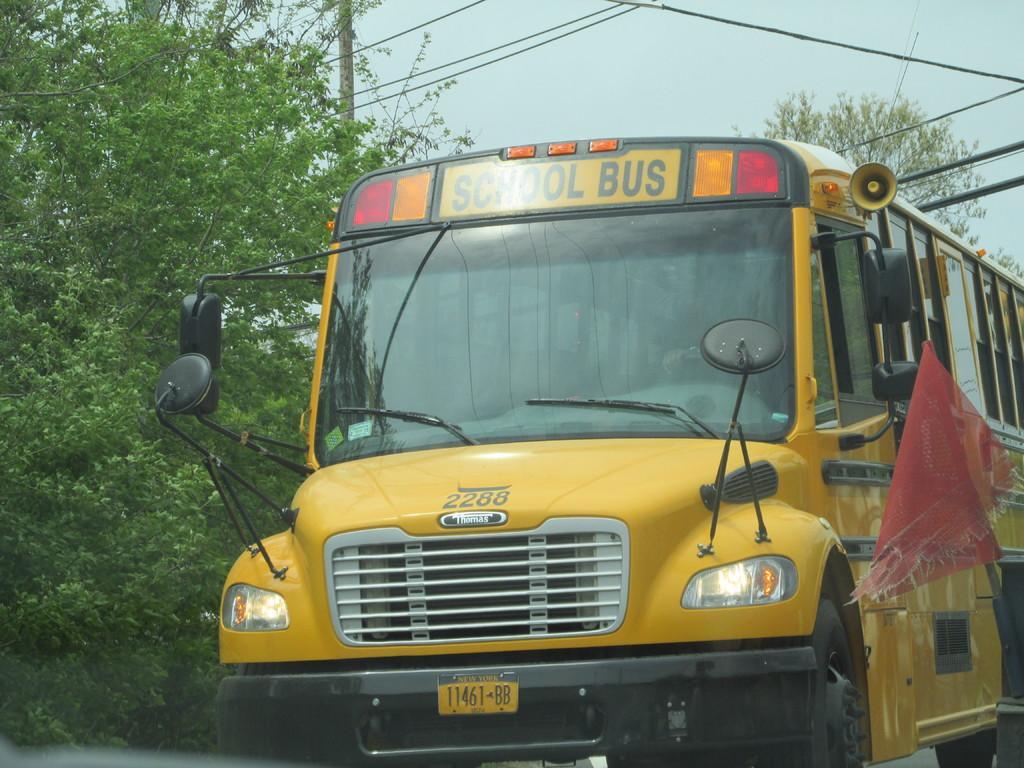Describe this image in one or two sentences. In the image we can see there is a yellow colour bus standing on the road and "School Bus" is written on it. Behind there are trees. 